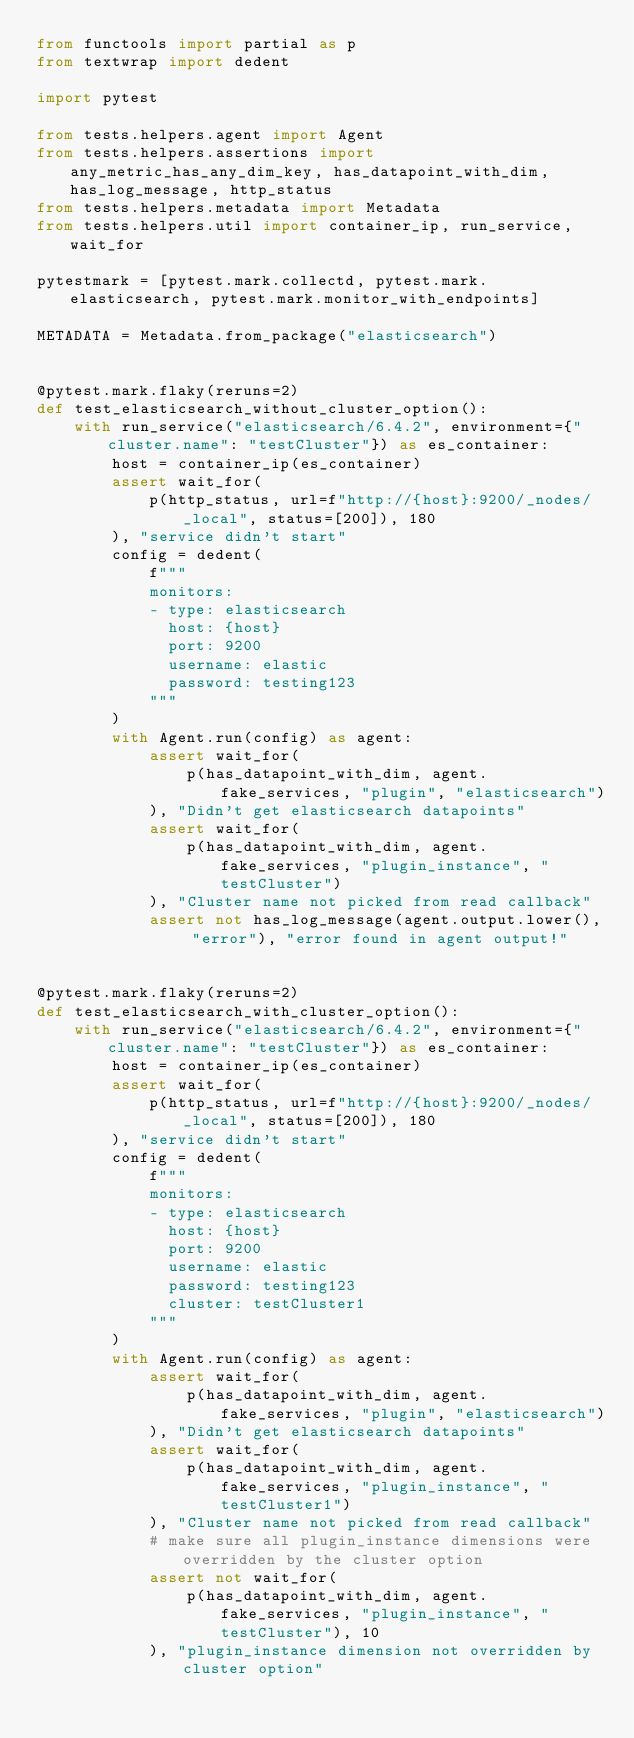<code> <loc_0><loc_0><loc_500><loc_500><_Python_>from functools import partial as p
from textwrap import dedent

import pytest

from tests.helpers.agent import Agent
from tests.helpers.assertions import any_metric_has_any_dim_key, has_datapoint_with_dim, has_log_message, http_status
from tests.helpers.metadata import Metadata
from tests.helpers.util import container_ip, run_service, wait_for

pytestmark = [pytest.mark.collectd, pytest.mark.elasticsearch, pytest.mark.monitor_with_endpoints]

METADATA = Metadata.from_package("elasticsearch")


@pytest.mark.flaky(reruns=2)
def test_elasticsearch_without_cluster_option():
    with run_service("elasticsearch/6.4.2", environment={"cluster.name": "testCluster"}) as es_container:
        host = container_ip(es_container)
        assert wait_for(
            p(http_status, url=f"http://{host}:9200/_nodes/_local", status=[200]), 180
        ), "service didn't start"
        config = dedent(
            f"""
            monitors:
            - type: elasticsearch
              host: {host}
              port: 9200
              username: elastic
              password: testing123
            """
        )
        with Agent.run(config) as agent:
            assert wait_for(
                p(has_datapoint_with_dim, agent.fake_services, "plugin", "elasticsearch")
            ), "Didn't get elasticsearch datapoints"
            assert wait_for(
                p(has_datapoint_with_dim, agent.fake_services, "plugin_instance", "testCluster")
            ), "Cluster name not picked from read callback"
            assert not has_log_message(agent.output.lower(), "error"), "error found in agent output!"


@pytest.mark.flaky(reruns=2)
def test_elasticsearch_with_cluster_option():
    with run_service("elasticsearch/6.4.2", environment={"cluster.name": "testCluster"}) as es_container:
        host = container_ip(es_container)
        assert wait_for(
            p(http_status, url=f"http://{host}:9200/_nodes/_local", status=[200]), 180
        ), "service didn't start"
        config = dedent(
            f"""
            monitors:
            - type: elasticsearch
              host: {host}
              port: 9200
              username: elastic
              password: testing123
              cluster: testCluster1
            """
        )
        with Agent.run(config) as agent:
            assert wait_for(
                p(has_datapoint_with_dim, agent.fake_services, "plugin", "elasticsearch")
            ), "Didn't get elasticsearch datapoints"
            assert wait_for(
                p(has_datapoint_with_dim, agent.fake_services, "plugin_instance", "testCluster1")
            ), "Cluster name not picked from read callback"
            # make sure all plugin_instance dimensions were overridden by the cluster option
            assert not wait_for(
                p(has_datapoint_with_dim, agent.fake_services, "plugin_instance", "testCluster"), 10
            ), "plugin_instance dimension not overridden by cluster option"</code> 